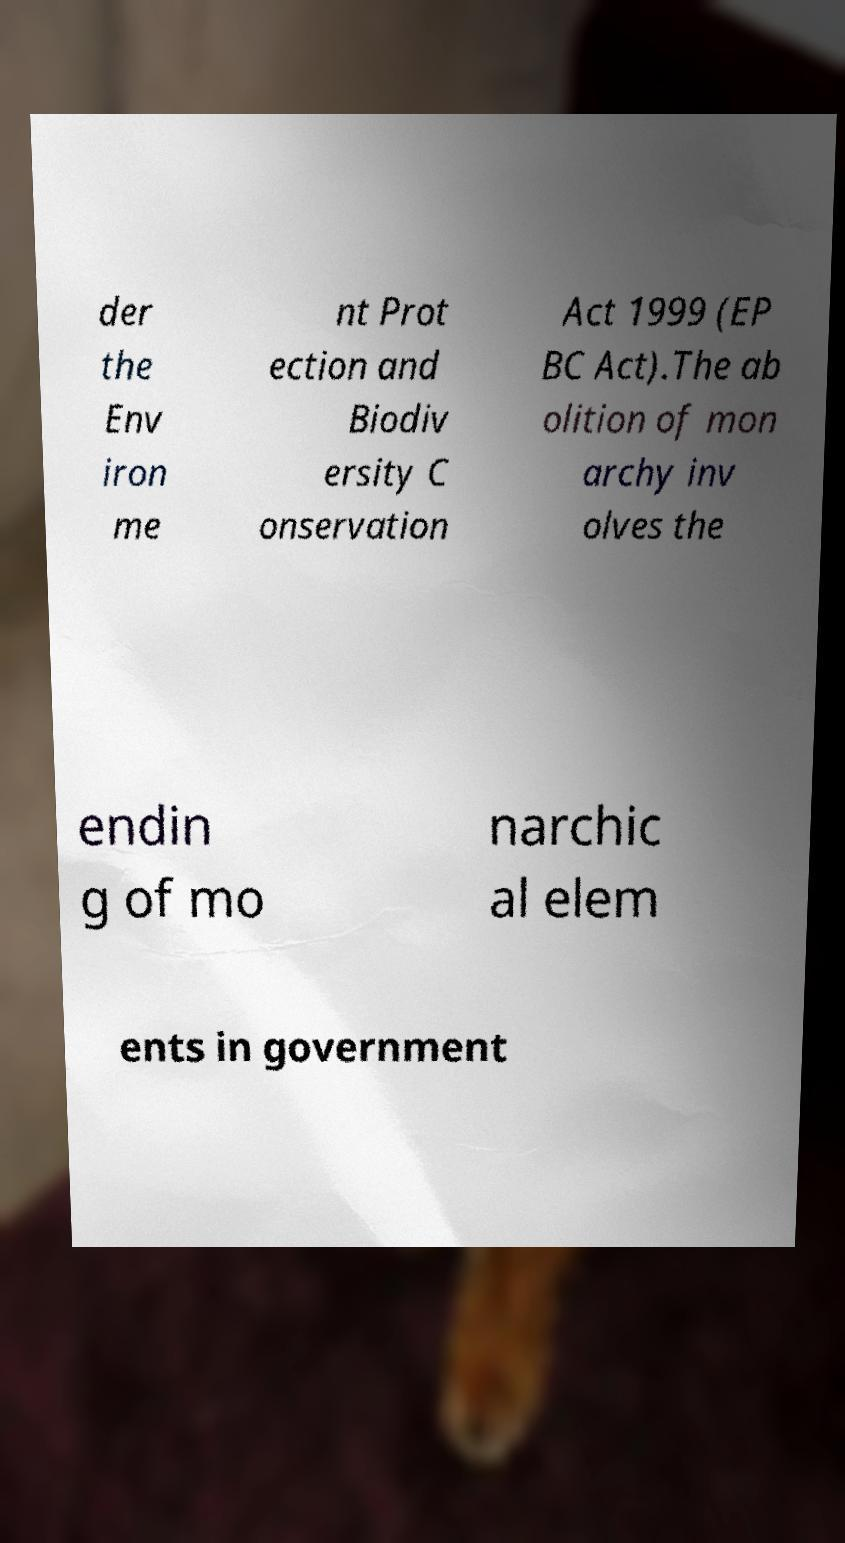What messages or text are displayed in this image? I need them in a readable, typed format. der the Env iron me nt Prot ection and Biodiv ersity C onservation Act 1999 (EP BC Act).The ab olition of mon archy inv olves the endin g of mo narchic al elem ents in government 